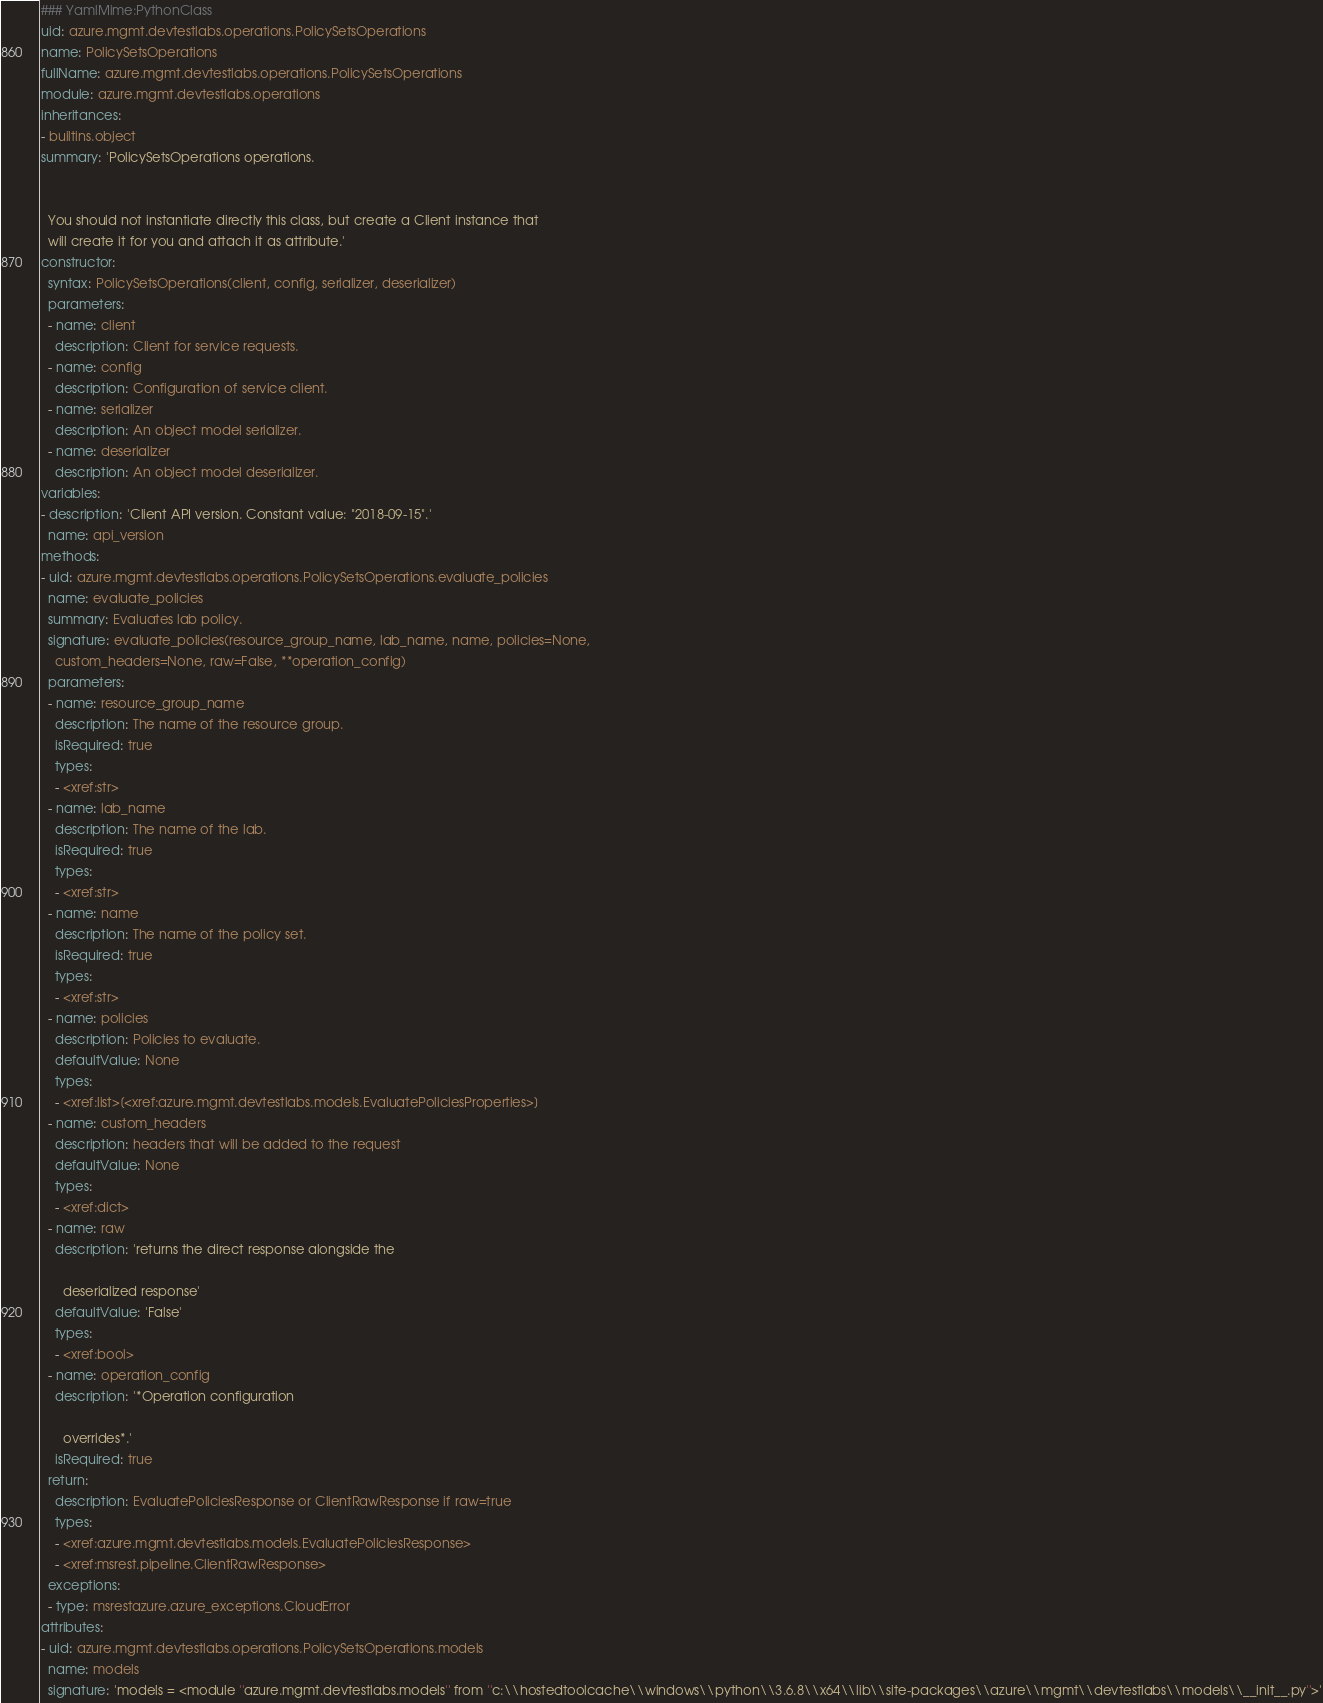Convert code to text. <code><loc_0><loc_0><loc_500><loc_500><_YAML_>### YamlMime:PythonClass
uid: azure.mgmt.devtestlabs.operations.PolicySetsOperations
name: PolicySetsOperations
fullName: azure.mgmt.devtestlabs.operations.PolicySetsOperations
module: azure.mgmt.devtestlabs.operations
inheritances:
- builtins.object
summary: 'PolicySetsOperations operations.


  You should not instantiate directly this class, but create a Client instance that
  will create it for you and attach it as attribute.'
constructor:
  syntax: PolicySetsOperations(client, config, serializer, deserializer)
  parameters:
  - name: client
    description: Client for service requests.
  - name: config
    description: Configuration of service client.
  - name: serializer
    description: An object model serializer.
  - name: deserializer
    description: An object model deserializer.
variables:
- description: 'Client API version. Constant value: "2018-09-15".'
  name: api_version
methods:
- uid: azure.mgmt.devtestlabs.operations.PolicySetsOperations.evaluate_policies
  name: evaluate_policies
  summary: Evaluates lab policy.
  signature: evaluate_policies(resource_group_name, lab_name, name, policies=None,
    custom_headers=None, raw=False, **operation_config)
  parameters:
  - name: resource_group_name
    description: The name of the resource group.
    isRequired: true
    types:
    - <xref:str>
  - name: lab_name
    description: The name of the lab.
    isRequired: true
    types:
    - <xref:str>
  - name: name
    description: The name of the policy set.
    isRequired: true
    types:
    - <xref:str>
  - name: policies
    description: Policies to evaluate.
    defaultValue: None
    types:
    - <xref:list>[<xref:azure.mgmt.devtestlabs.models.EvaluatePoliciesProperties>]
  - name: custom_headers
    description: headers that will be added to the request
    defaultValue: None
    types:
    - <xref:dict>
  - name: raw
    description: 'returns the direct response alongside the

      deserialized response'
    defaultValue: 'False'
    types:
    - <xref:bool>
  - name: operation_config
    description: '*Operation configuration

      overrides*.'
    isRequired: true
  return:
    description: EvaluatePoliciesResponse or ClientRawResponse if raw=true
    types:
    - <xref:azure.mgmt.devtestlabs.models.EvaluatePoliciesResponse>
    - <xref:msrest.pipeline.ClientRawResponse>
  exceptions:
  - type: msrestazure.azure_exceptions.CloudError
attributes:
- uid: azure.mgmt.devtestlabs.operations.PolicySetsOperations.models
  name: models
  signature: 'models = <module ''azure.mgmt.devtestlabs.models'' from ''c:\\hostedtoolcache\\windows\\python\\3.6.8\\x64\\lib\\site-packages\\azure\\mgmt\\devtestlabs\\models\\__init__.py''>'
</code> 